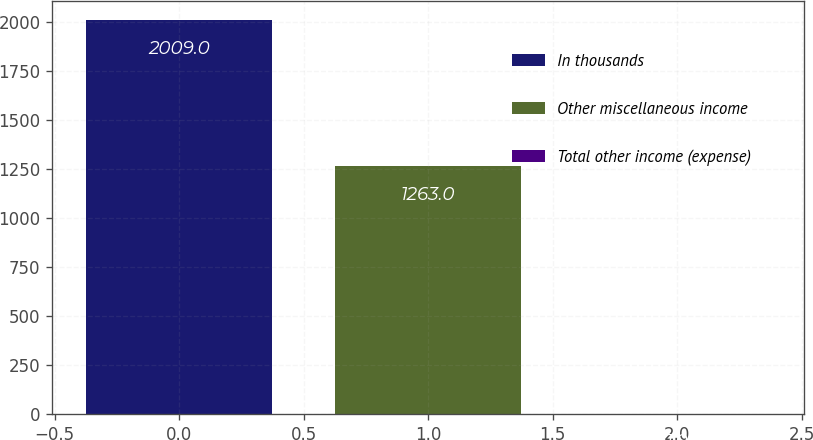Convert chart. <chart><loc_0><loc_0><loc_500><loc_500><bar_chart><fcel>In thousands<fcel>Other miscellaneous income<fcel>Total other income (expense)<nl><fcel>2009<fcel>1263<fcel>1<nl></chart> 